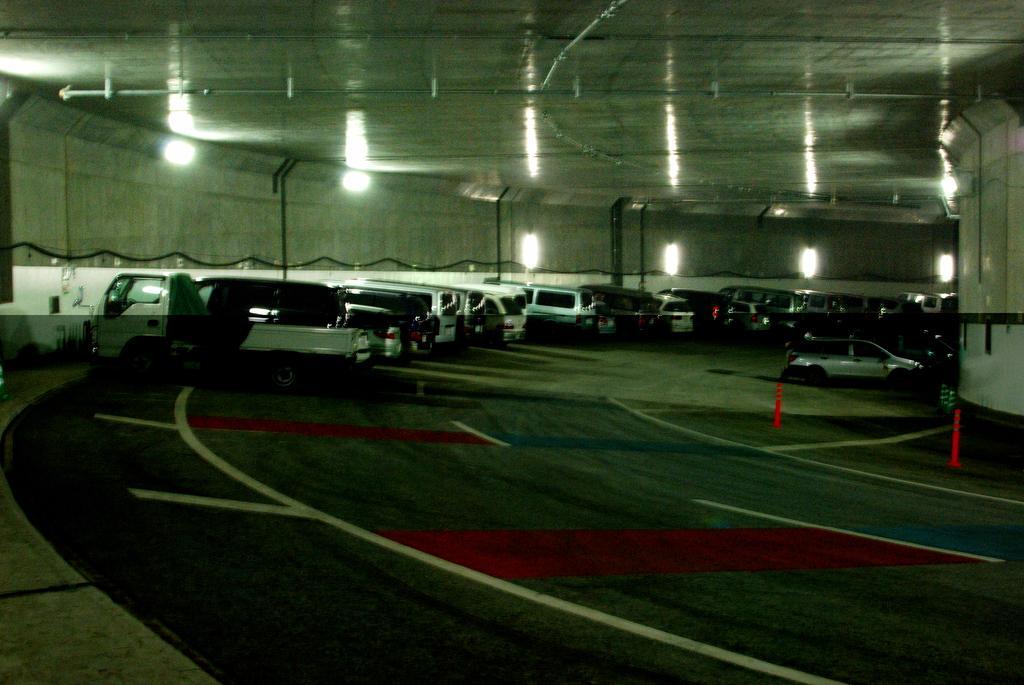Can you describe this image briefly? In the center of the image, we can see vehicles on the road and there are traffic cones and in the background, we can see rods. At the top, there are lights and we can see a roof and on the right, there is a pillar. 